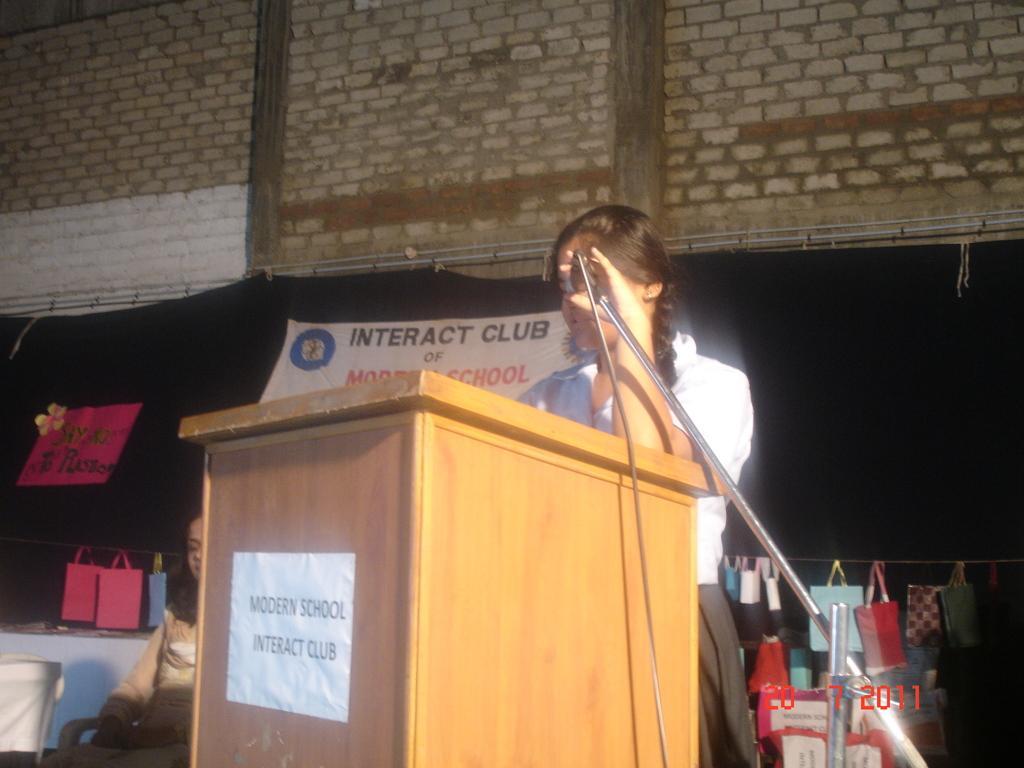Could you give a brief overview of what you see in this image? This image consists of a banner backside. There is a podium in the middle. A woman is standing near the podium. She is holding Mike. There is a mic stand. There are bags in the bottom right corner. There is a woman sitting on the left side bottom. There is a wall on the top. 